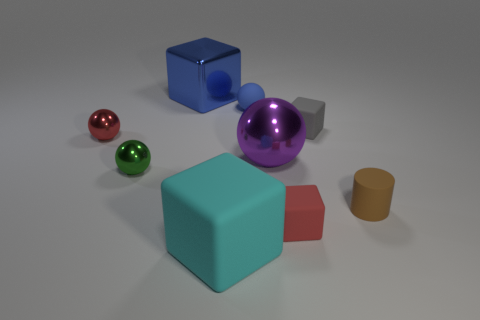Subtract all large metallic cubes. How many cubes are left? 3 Subtract all blue balls. How many balls are left? 3 Add 8 blue things. How many blue things are left? 10 Add 5 tiny blocks. How many tiny blocks exist? 7 Subtract 1 purple balls. How many objects are left? 8 Subtract all cylinders. How many objects are left? 8 Subtract all gray blocks. Subtract all purple spheres. How many blocks are left? 3 Subtract all big blue shiny blocks. Subtract all large blue matte cubes. How many objects are left? 8 